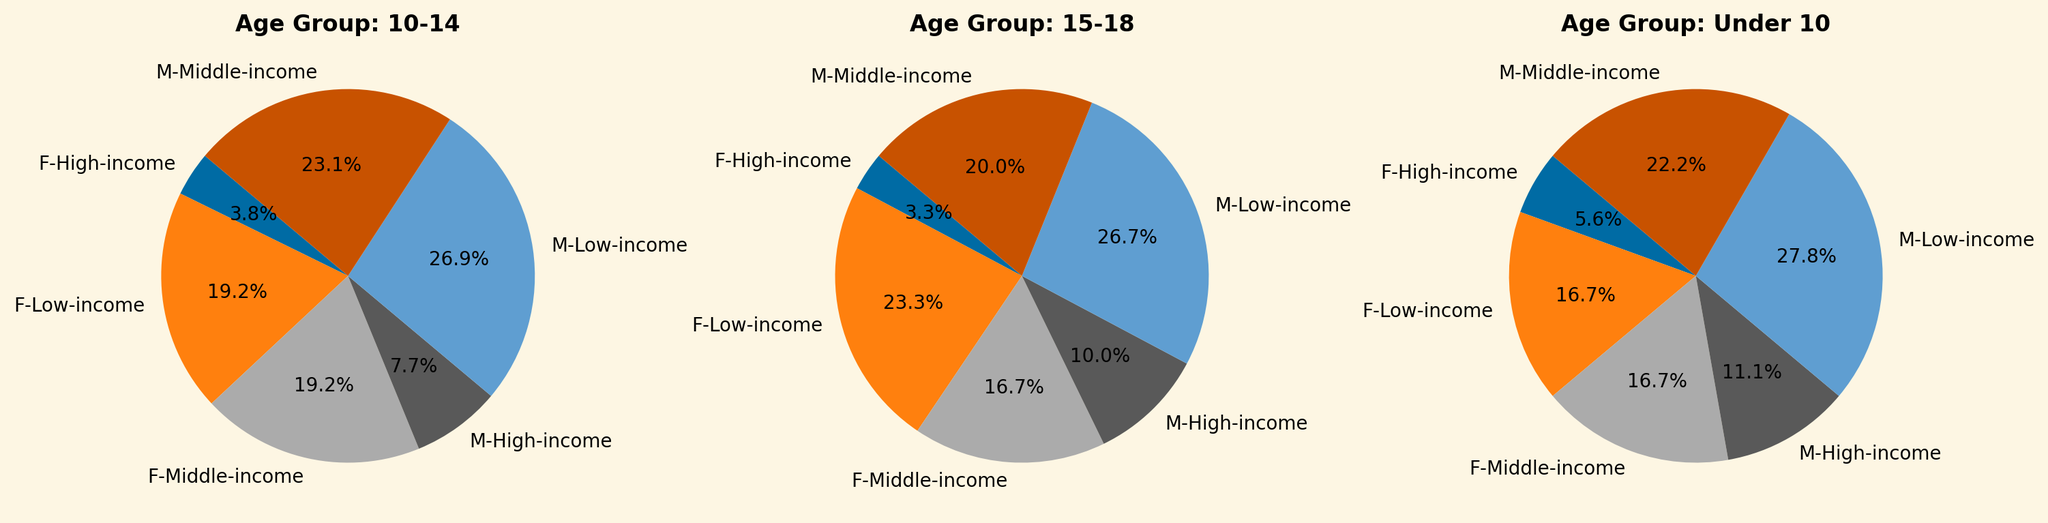What age group has the highest proportion of boys from low-income backgrounds involved in football? By looking at the pie charts, focus on the "M-Low-income" segment in each age group. Compare the proportions visually to identify which pie slice is the largest. The largest segment is in the 15-18 age group.
Answer: 15-18 In the 10-14 age group, what percentage of participants are girls from middle-income backgrounds? Focus on the pie chart labeled "Age Group: 10-14". Find the slice labeled "F-Middle-income" and read the percentage directly off the slice.
Answer: 5% Which age group shows the highest proportion of girls from high-income backgrounds? Examine the pie charts for all age groups, looking for the "F-High-income" slices. The pie chart with the largest "F-High-income" slice is in the 15-18 age group.
Answer: 15-18 Comparing boys and girls in the under 10 age group, do boys from low-income backgrounds comprise a larger percentage than girls from low-income backgrounds? Look at the "Age Group: Under 10" pie chart and compare the slices labeled "M-Low-income" and "F-Low-income". "M-Low-income" is larger than "F-Low-income", indicating that boys comprise a larger percentage.
Answer: Yes What is the total percentage of participants from high-income backgrounds in the 15-18 age group? In the 15-18 age group pie chart, sum the percentages for "M-High-income" and "F-High-income" slices. 3% (M-High-income) + 1% (F-High-income) = 4%.
Answer: 4% Which socio-economic background has the least representation in the under 10 age group? Look at the "Age Group: Under 10" pie chart and compare the sizes of the slices for each socio-economic background. The "High-income" background (1% and 2% for girls and boys respectively) has the smallest slices.
Answer: High-income In the 10-14 age group, what’s the difference in percentage between boys from middle-income backgrounds and boys from high-income backgrounds? Find the percentages of "M-Middle-income" and "M-High-income" slices in the 10-14 age group. The difference is calculated as 6% (M-Middle-income) - 2% (M-High-income) = 4%.
Answer: 4% In the 15-18 age group, how does the percentage of girls from low-income backgrounds compare to boys from the same background? In the "Age Group: 15-18" pie chart, compare the "F-Low-income" slice to the "M-Low-income" slice. "F-Low-income" is 7%, and "M-Low-income" is 8%.
Answer: Girls: 7%, Boys: 8% What is the most common socio-economic background for football participants across all age groups? Observe the pie charts for all age groups and identify the socio-economic background that appears most frequently with the largest slices. "Low-income" has consistently large slices across all age groups.
Answer: Low-income In the under 10 age group, what’s the combined percentage of boys from middle-income and high-income backgrounds? Sum the percentages of "M-Middle-income" and "M-High-income" slices in the "Under 10" pie chart. 4% (M-Middle-income) + 2% (M-High-income) = 6%.
Answer: 6% 